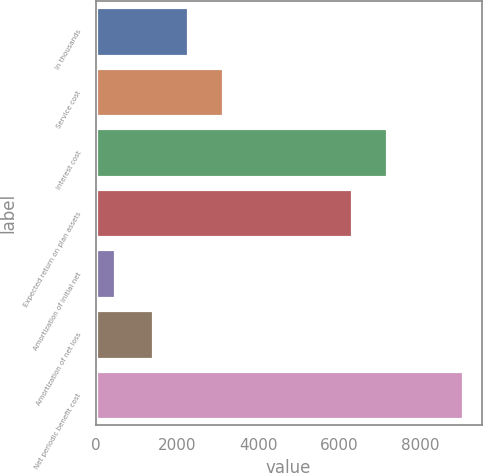Convert chart to OTSL. <chart><loc_0><loc_0><loc_500><loc_500><bar_chart><fcel>In thousands<fcel>Service cost<fcel>Interest cost<fcel>Expected return on plan assets<fcel>Amortization of initial net<fcel>Amortization of net loss<fcel>Net periodic benefit cost<nl><fcel>2276.5<fcel>3135<fcel>7169.5<fcel>6311<fcel>467<fcel>1418<fcel>9052<nl></chart> 